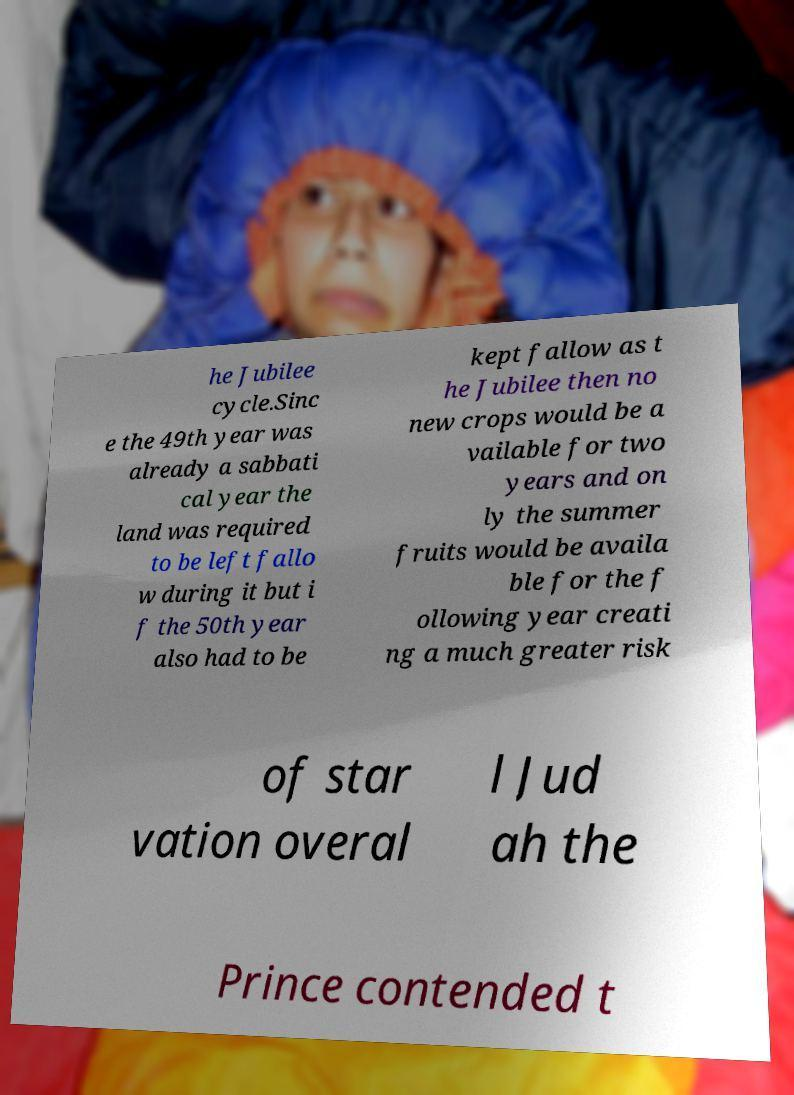Please read and relay the text visible in this image. What does it say? he Jubilee cycle.Sinc e the 49th year was already a sabbati cal year the land was required to be left fallo w during it but i f the 50th year also had to be kept fallow as t he Jubilee then no new crops would be a vailable for two years and on ly the summer fruits would be availa ble for the f ollowing year creati ng a much greater risk of star vation overal l Jud ah the Prince contended t 